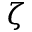Convert formula to latex. <formula><loc_0><loc_0><loc_500><loc_500>\zeta</formula> 